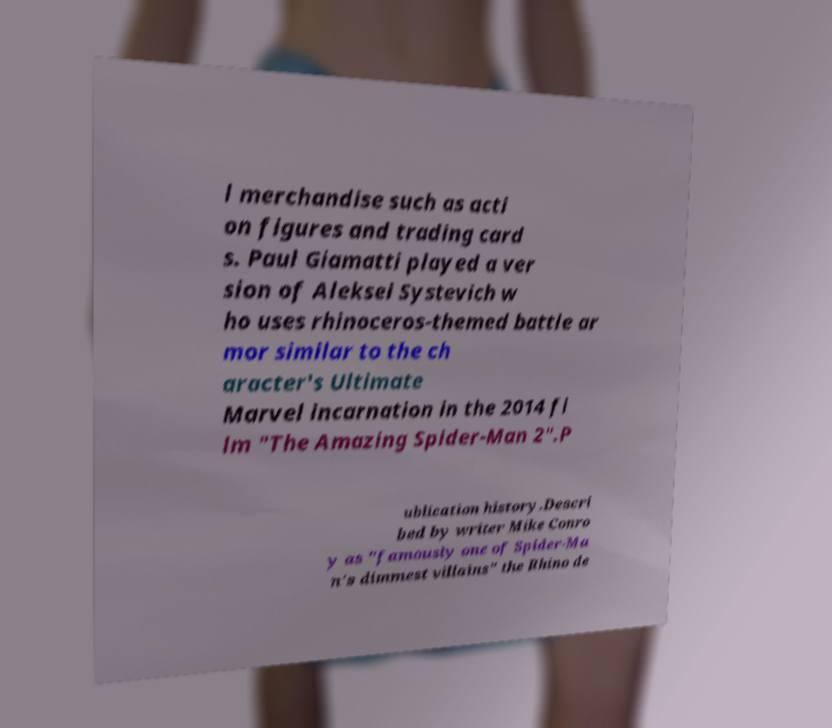What messages or text are displayed in this image? I need them in a readable, typed format. l merchandise such as acti on figures and trading card s. Paul Giamatti played a ver sion of Aleksei Systevich w ho uses rhinoceros-themed battle ar mor similar to the ch aracter's Ultimate Marvel incarnation in the 2014 fi lm "The Amazing Spider-Man 2".P ublication history.Descri bed by writer Mike Conro y as "famously one of Spider-Ma n's dimmest villains" the Rhino de 